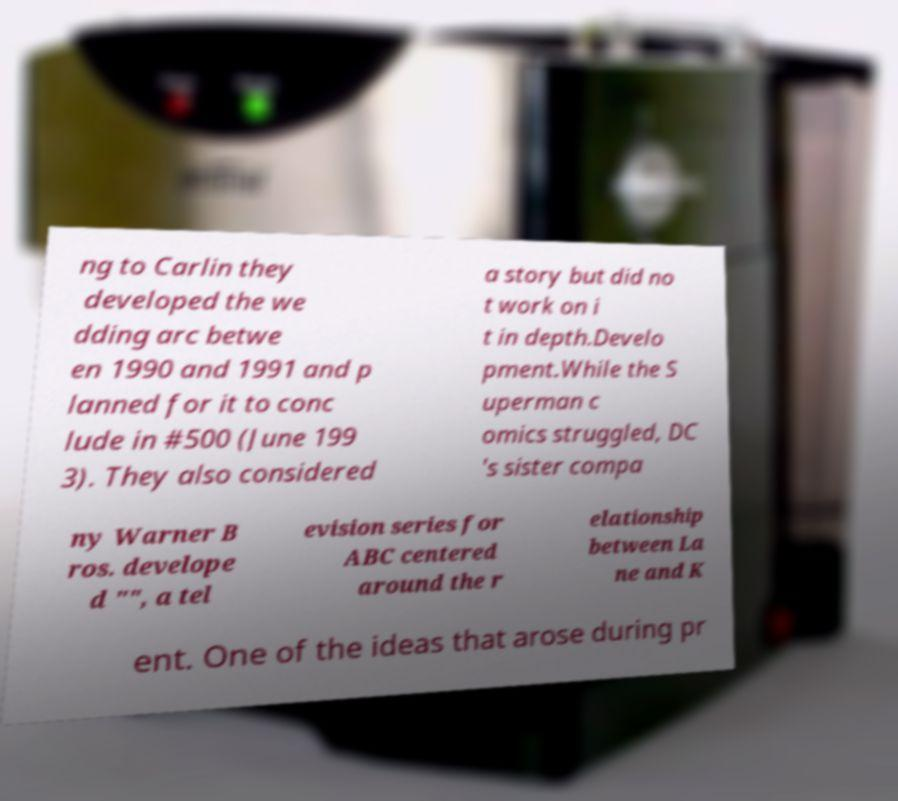Can you read and provide the text displayed in the image?This photo seems to have some interesting text. Can you extract and type it out for me? ng to Carlin they developed the we dding arc betwe en 1990 and 1991 and p lanned for it to conc lude in #500 (June 199 3). They also considered a story but did no t work on i t in depth.Develo pment.While the S uperman c omics struggled, DC 's sister compa ny Warner B ros. develope d "", a tel evision series for ABC centered around the r elationship between La ne and K ent. One of the ideas that arose during pr 